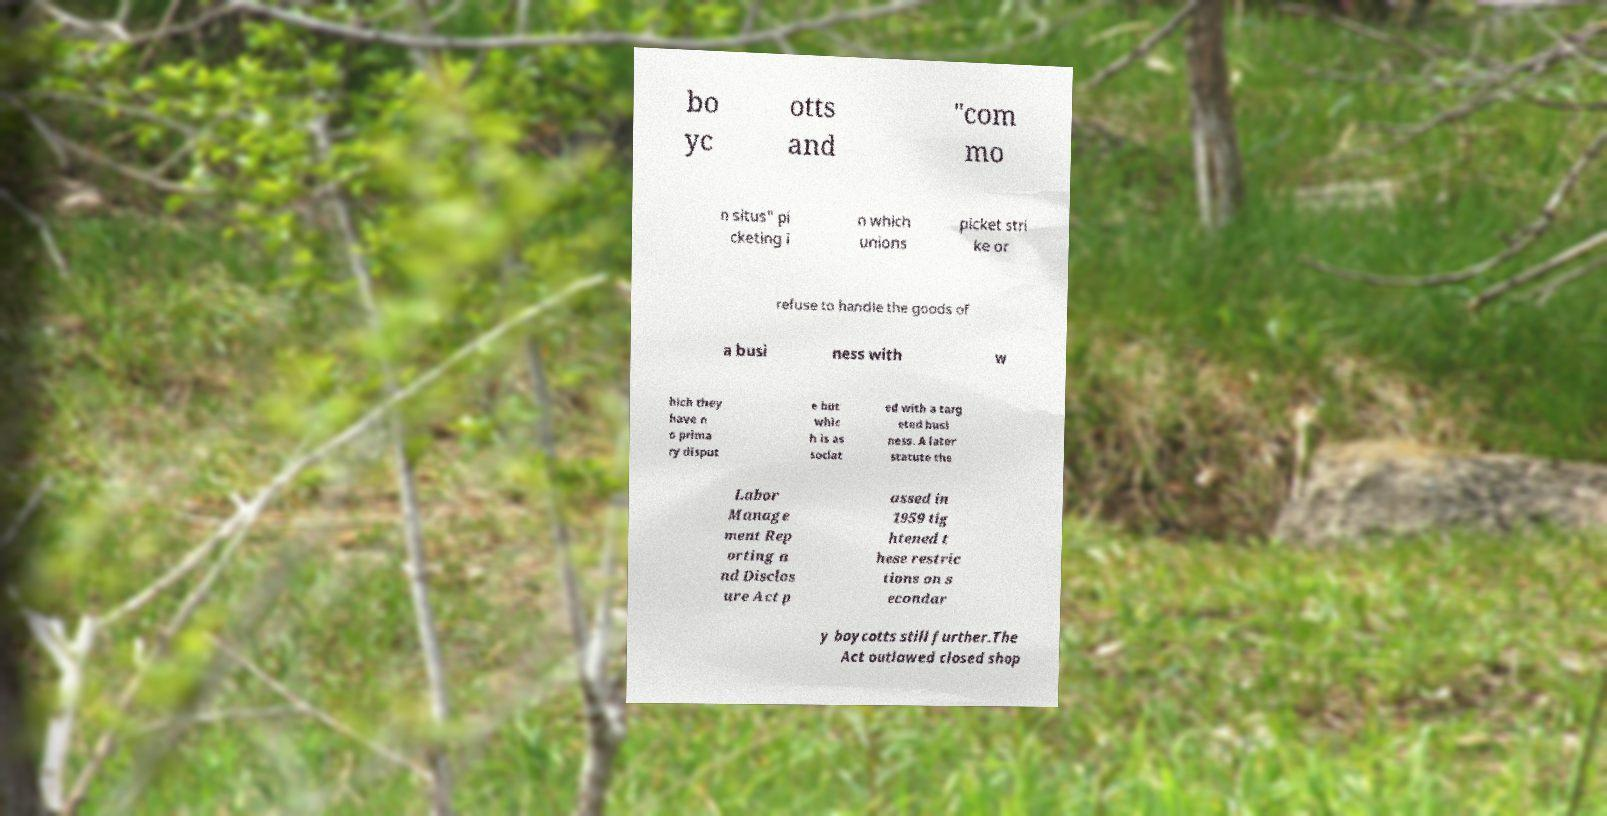Can you accurately transcribe the text from the provided image for me? bo yc otts and "com mo n situs" pi cketing i n which unions picket stri ke or refuse to handle the goods of a busi ness with w hich they have n o prima ry disput e but whic h is as sociat ed with a targ eted busi ness. A later statute the Labor Manage ment Rep orting a nd Disclos ure Act p assed in 1959 tig htened t hese restric tions on s econdar y boycotts still further.The Act outlawed closed shop 